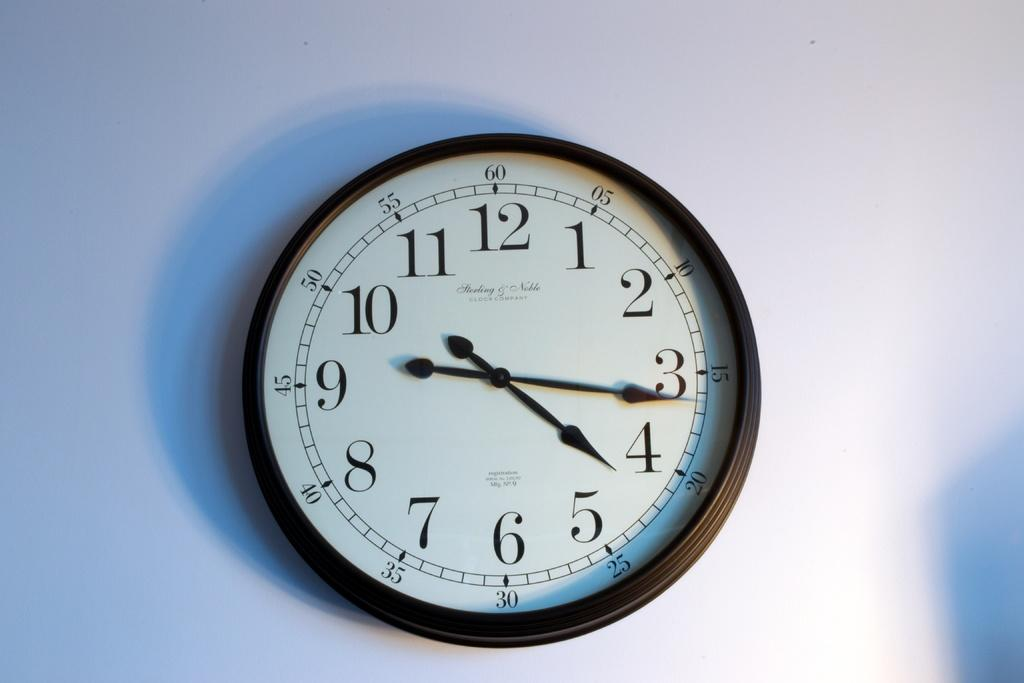<image>
Provide a brief description of the given image. The clock on the wall states that the time is 4:16. 